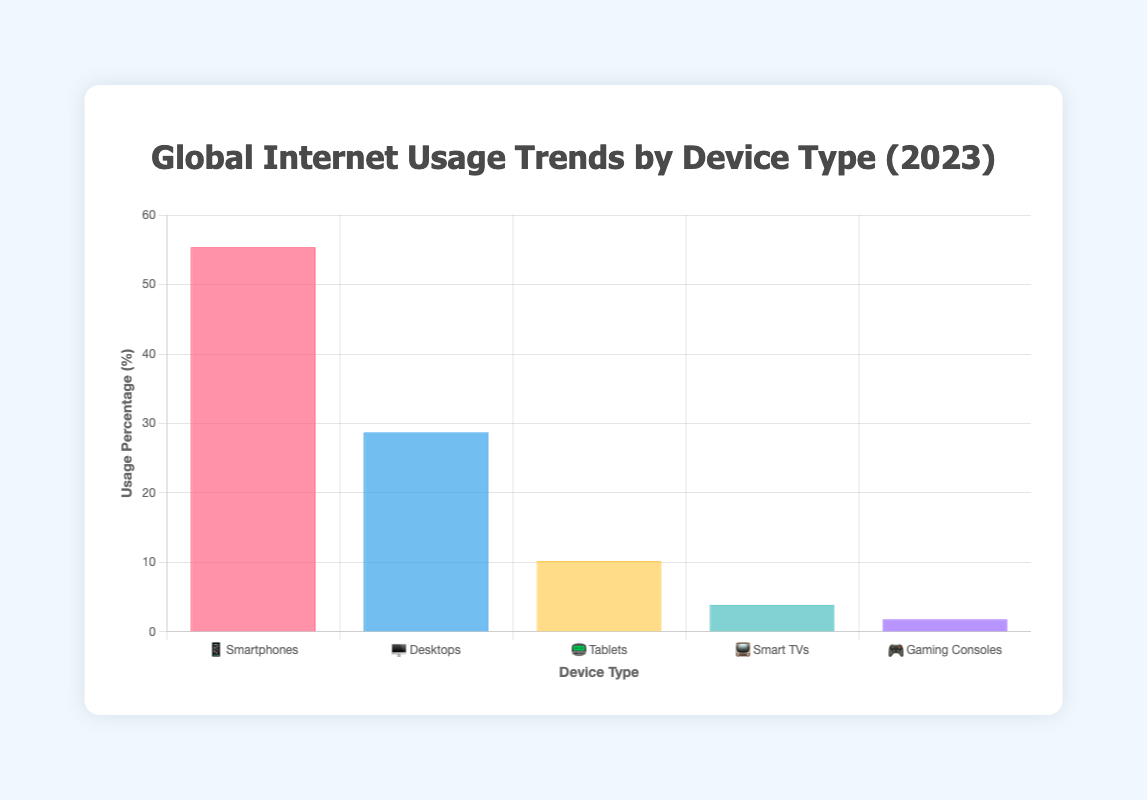What is the title of the chart? The title is shown at the top of the chart in bold text. By reading it, we see it specifies "Global Internet Usage Trends by Device Type (2023)".
Answer: Global Internet Usage Trends by Device Type (2023) Which device type has the highest usage percentage? By examining the heights of the bars, we see the bar labeled "📱 Smartphones" is the tallest, indicating the highest usage percentage.
Answer: Smartphones Which device type has the lowest usage percentage? By looking at the heights of the bars, we see the bar labeled "🎮 Gaming Consoles" is the shortest, indicating the lowest usage percentage.
Answer: Gaming Consoles What is the combined usage percentage of Tablets 📟 and Smart TVs 📺? Adding the percentage for Tablets (10.2%) and Smart TVs (3.9%) gives us 10.2 + 3.9 = 14.1.
Answer: 14.1% How does the usage percentage of Desktops 🖥️ compare to that of Smart TVs 📺? The bar for Desktops is taller than the bar for Smart TVs. Desktops have 28.7%, while Smart TVs have 3.9%. Therefore, Desktops have a higher usage percentage.
Answer: Desktops have a higher usage percentage than Smart TVs Which device type shows a negative growth rate, and what is its usage percentage? By reading the information provided, we see "🖥️ Desktops" has a growth rate of -1.5. Its usage percentage is shown as 28.7%.
Answer: Desktops, 28.7% What is the average usage percentage of all device types? Sum the percentages of all device types (55.4 + 28.7 + 10.2 + 3.9 + 1.8) = 100 and divide by the number of devices (5). 100/5 = 20.0.
Answer: 20.0% How does the usage percentage of Gaming Consoles 🎮 compare with that of Smart TVs 📺? Gaming Consoles have a usage percentage of 1.8%, while Smart TVs have 3.9%. Comparing these shows Smart TVs have a higher percentage.
Answer: Smart TVs have a higher usage percentage than Gaming Consoles What is the total number of global internet users represented by the chart? The total number of users, according to the given data, is clearly mentioned as 4.66 billion.
Answer: 4.66 billion 